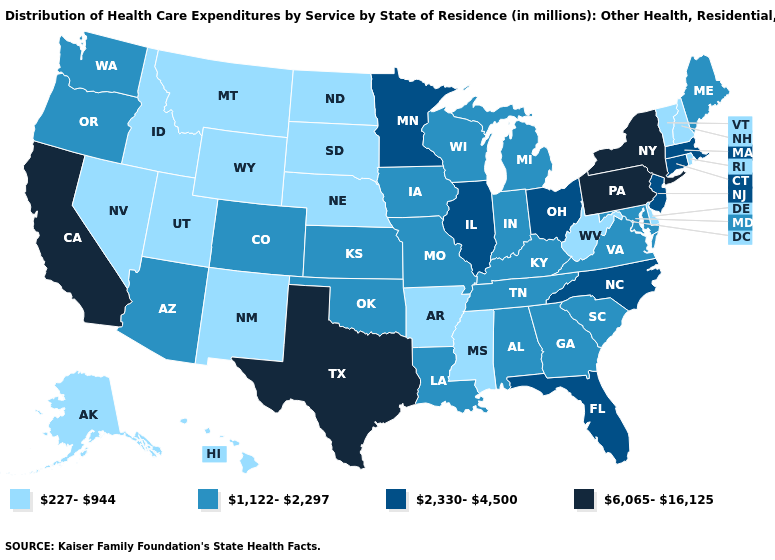What is the value of Minnesota?
Quick response, please. 2,330-4,500. Which states hav the highest value in the South?
Give a very brief answer. Texas. What is the lowest value in the West?
Quick response, please. 227-944. What is the lowest value in states that border Minnesota?
Concise answer only. 227-944. Name the states that have a value in the range 2,330-4,500?
Quick response, please. Connecticut, Florida, Illinois, Massachusetts, Minnesota, New Jersey, North Carolina, Ohio. Which states have the highest value in the USA?
Concise answer only. California, New York, Pennsylvania, Texas. What is the value of Montana?
Be succinct. 227-944. Name the states that have a value in the range 227-944?
Write a very short answer. Alaska, Arkansas, Delaware, Hawaii, Idaho, Mississippi, Montana, Nebraska, Nevada, New Hampshire, New Mexico, North Dakota, Rhode Island, South Dakota, Utah, Vermont, West Virginia, Wyoming. Which states have the lowest value in the South?
Keep it brief. Arkansas, Delaware, Mississippi, West Virginia. Name the states that have a value in the range 1,122-2,297?
Answer briefly. Alabama, Arizona, Colorado, Georgia, Indiana, Iowa, Kansas, Kentucky, Louisiana, Maine, Maryland, Michigan, Missouri, Oklahoma, Oregon, South Carolina, Tennessee, Virginia, Washington, Wisconsin. What is the value of Hawaii?
Be succinct. 227-944. Does Missouri have the lowest value in the USA?
Quick response, please. No. What is the highest value in the West ?
Write a very short answer. 6,065-16,125. What is the value of Indiana?
Quick response, please. 1,122-2,297. 